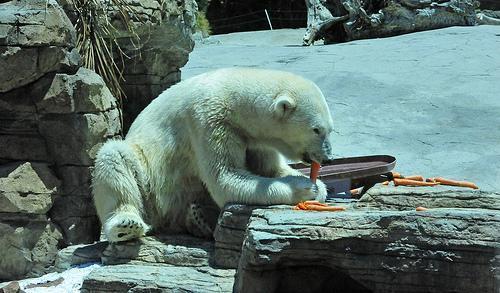How many polar bears are in the photo?
Give a very brief answer. 1. How many rock formations are there?
Give a very brief answer. 3. 